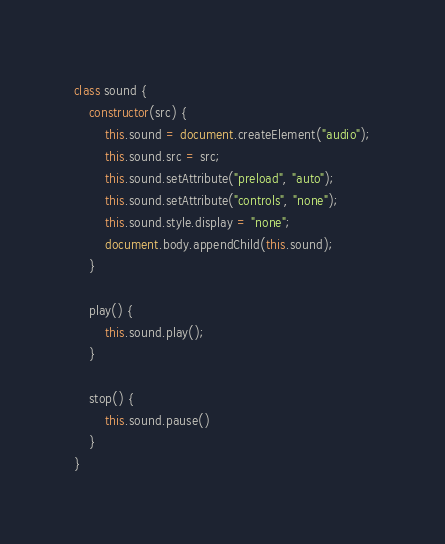<code> <loc_0><loc_0><loc_500><loc_500><_JavaScript_>class sound {
    constructor(src) {
        this.sound = document.createElement("audio");
        this.sound.src = src;
        this.sound.setAttribute("preload", "auto");
        this.sound.setAttribute("controls", "none");
        this.sound.style.display = "none";
        document.body.appendChild(this.sound);
    }

    play() {
        this.sound.play();
    }

    stop() {
        this.sound.pause()
    }
}
</code> 